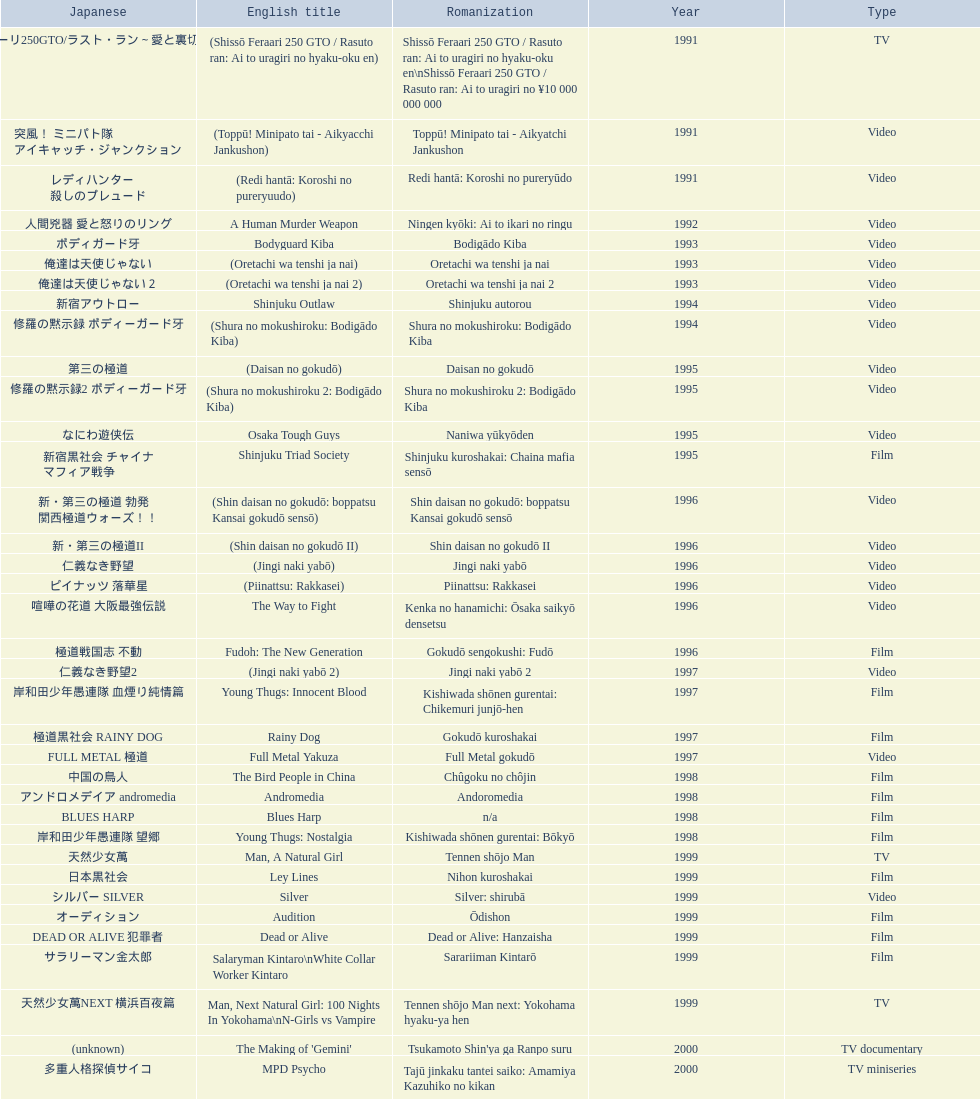Which title is listed next after "the way to fight"? Fudoh: The New Generation. 